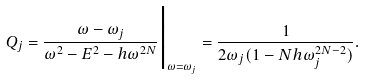<formula> <loc_0><loc_0><loc_500><loc_500>Q _ { j } = { \frac { \omega - \omega _ { j } } { \omega ^ { 2 } - E ^ { 2 } - h \omega ^ { 2 N } } } \Big | _ { \omega = \omega _ { j } } = { \frac { 1 } { 2 \omega _ { j } ( 1 - N h \omega _ { j } ^ { 2 N - 2 } ) } } .</formula> 